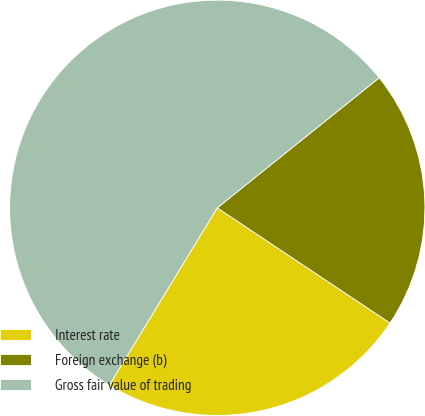<chart> <loc_0><loc_0><loc_500><loc_500><pie_chart><fcel>Interest rate<fcel>Foreign exchange (b)<fcel>Gross fair value of trading<nl><fcel>24.34%<fcel>20.13%<fcel>55.53%<nl></chart> 